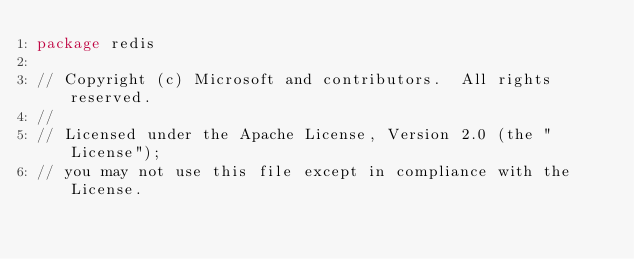Convert code to text. <code><loc_0><loc_0><loc_500><loc_500><_Go_>package redis

// Copyright (c) Microsoft and contributors.  All rights reserved.
//
// Licensed under the Apache License, Version 2.0 (the "License");
// you may not use this file except in compliance with the License.</code> 